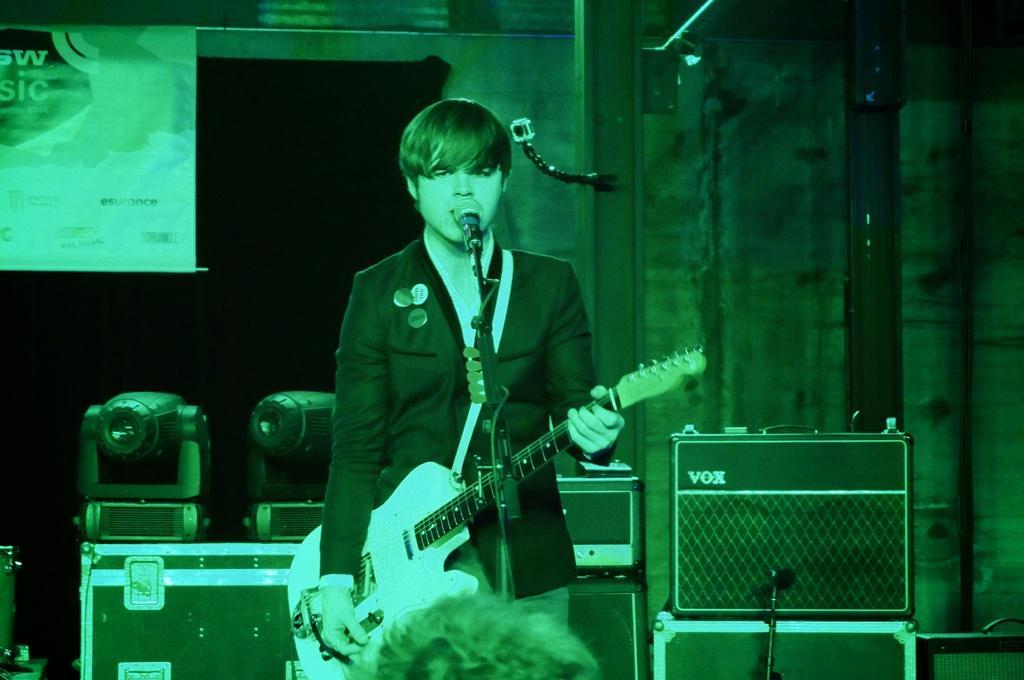Please provide a concise description of this image. In the image we can see man holding guitar playing it and singing in front of a microphone. On right side we can see a camera,pillars,speaker on left side we can see hoarding in which it is written something. 